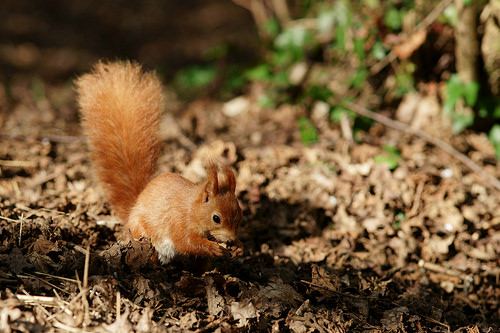<image>
Can you confirm if the squirrel is above the ground? No. The squirrel is not positioned above the ground. The vertical arrangement shows a different relationship. 